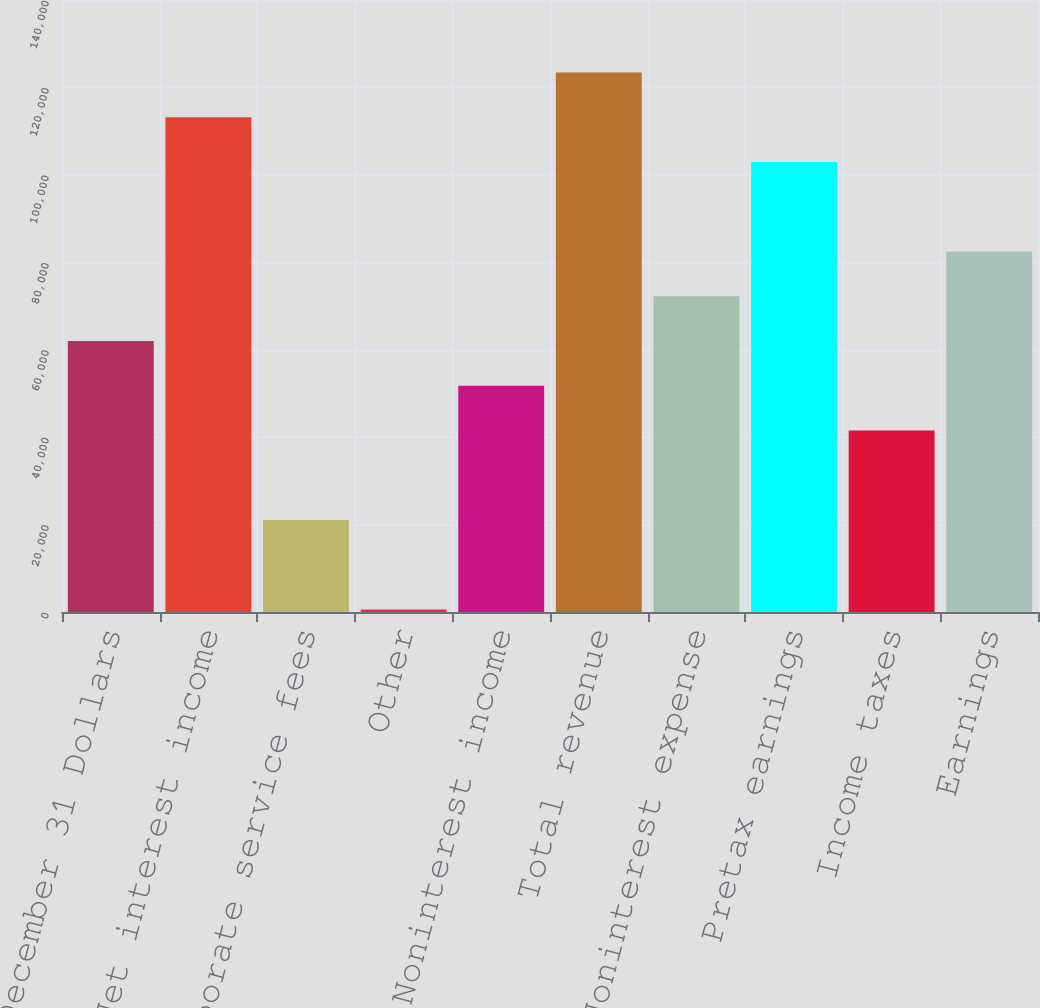Convert chart. <chart><loc_0><loc_0><loc_500><loc_500><bar_chart><fcel>Year ended December 31 Dollars<fcel>Net interest income<fcel>Corporate service fees<fcel>Other<fcel>Noninterest income<fcel>Total revenue<fcel>Noninterest expense<fcel>Pretax earnings<fcel>Income taxes<fcel>Earnings<nl><fcel>62004.4<fcel>113201<fcel>21046.8<fcel>568<fcel>51765<fcel>123441<fcel>72243.8<fcel>102962<fcel>41525.6<fcel>82483.2<nl></chart> 